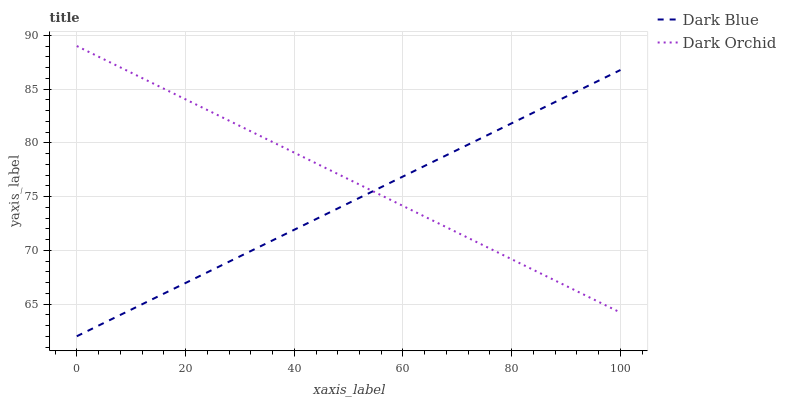Does Dark Orchid have the minimum area under the curve?
Answer yes or no. No. Is Dark Orchid the roughest?
Answer yes or no. No. Does Dark Orchid have the lowest value?
Answer yes or no. No. 